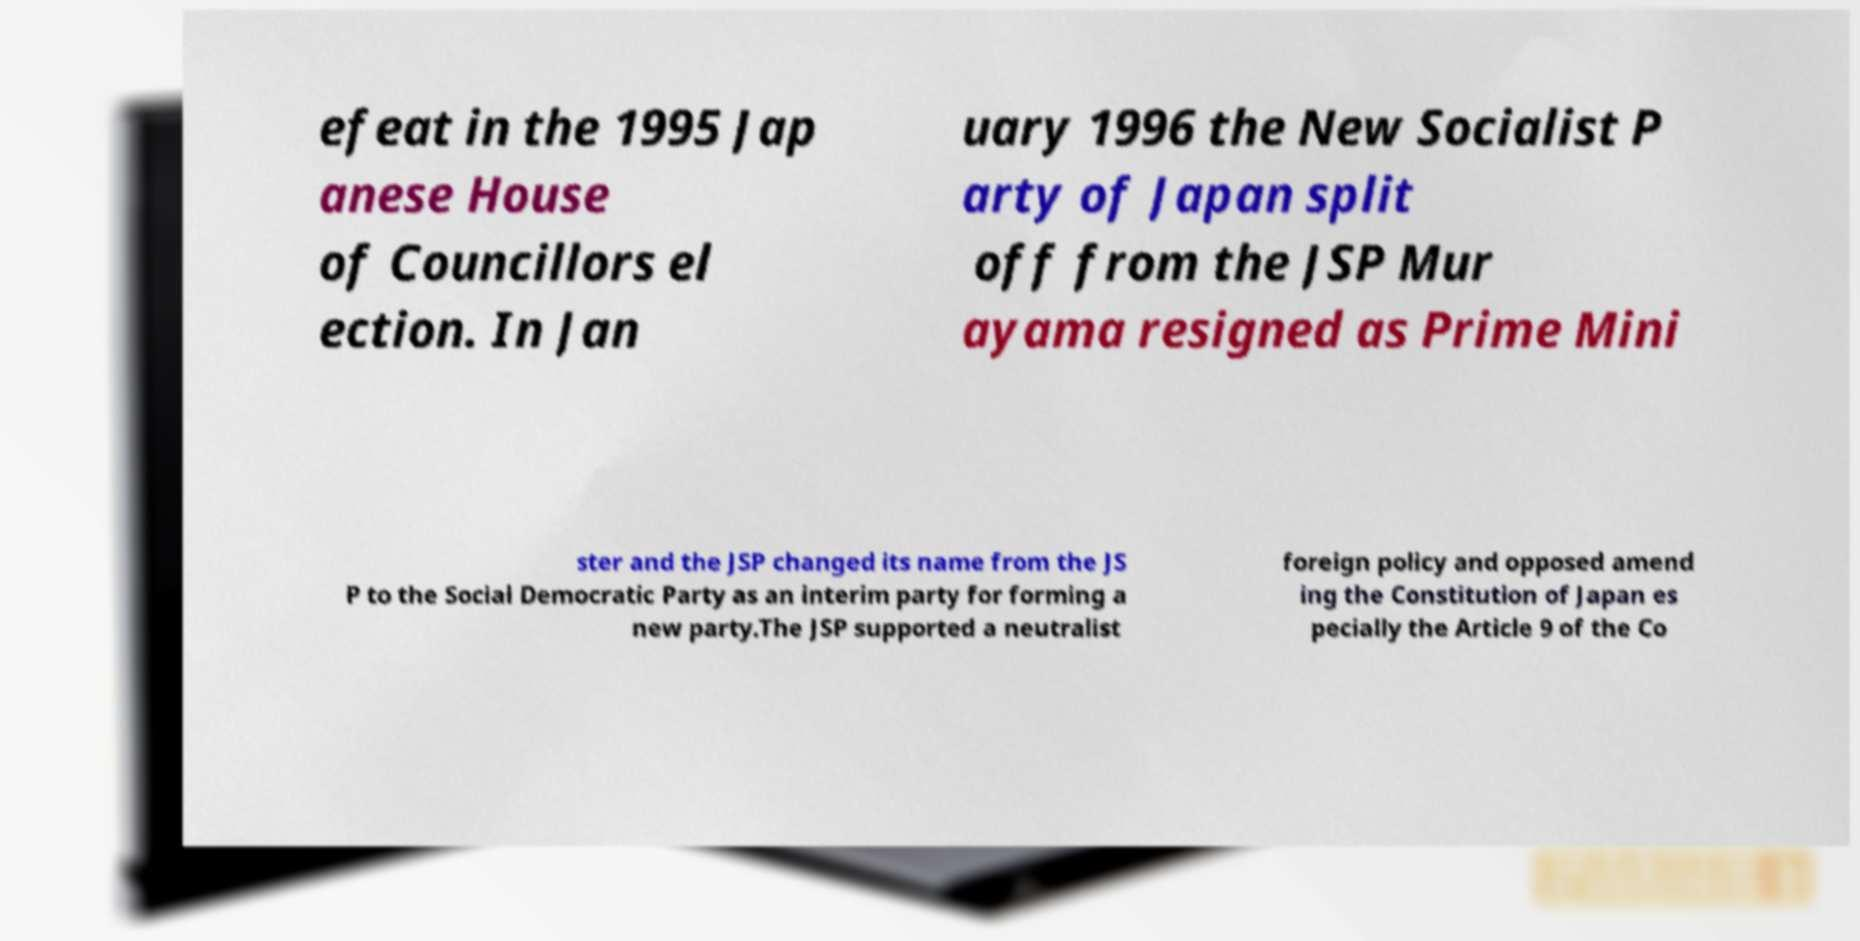For documentation purposes, I need the text within this image transcribed. Could you provide that? efeat in the 1995 Jap anese House of Councillors el ection. In Jan uary 1996 the New Socialist P arty of Japan split off from the JSP Mur ayama resigned as Prime Mini ster and the JSP changed its name from the JS P to the Social Democratic Party as an interim party for forming a new party.The JSP supported a neutralist foreign policy and opposed amend ing the Constitution of Japan es pecially the Article 9 of the Co 